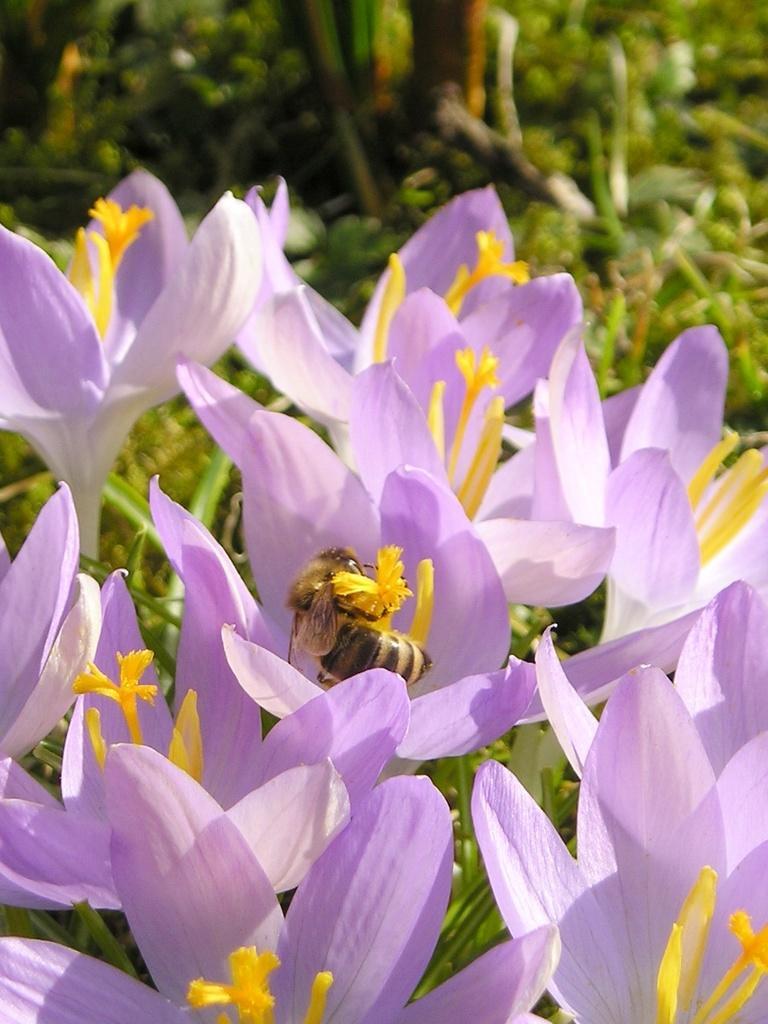Describe this image in one or two sentences. In this image, we can see some flowers. There are bees in the middle of the image. In the background, image is blurred. 